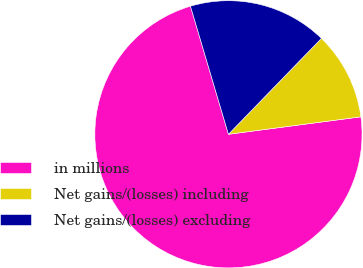Convert chart. <chart><loc_0><loc_0><loc_500><loc_500><pie_chart><fcel>in millions<fcel>Net gains/(losses) including<fcel>Net gains/(losses) excluding<nl><fcel>72.5%<fcel>10.66%<fcel>16.84%<nl></chart> 